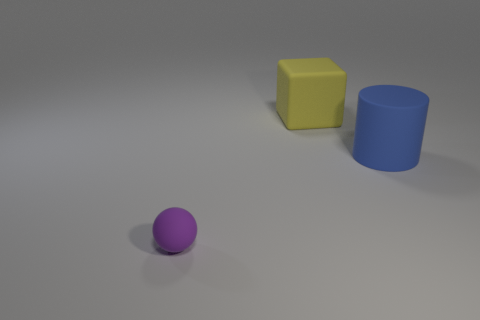What number of cylinders are either brown matte things or blue rubber things?
Your answer should be very brief. 1. What color is the large matte thing to the left of the blue rubber object?
Keep it short and to the point. Yellow. What shape is the object that is the same size as the blue rubber cylinder?
Your response must be concise. Cube. There is a cylinder; what number of large blue rubber objects are behind it?
Offer a terse response. 0. How many objects are either big blue balls or yellow things?
Your response must be concise. 1. There is a thing that is behind the tiny purple matte ball and left of the large blue rubber object; what is its shape?
Provide a succinct answer. Cube. How many blue matte cylinders are there?
Make the answer very short. 1. There is a tiny ball that is the same material as the large blue cylinder; what is its color?
Make the answer very short. Purple. Is the number of purple things greater than the number of big green blocks?
Your response must be concise. Yes. What size is the matte object that is on the right side of the small purple rubber ball and to the left of the large cylinder?
Ensure brevity in your answer.  Large. 